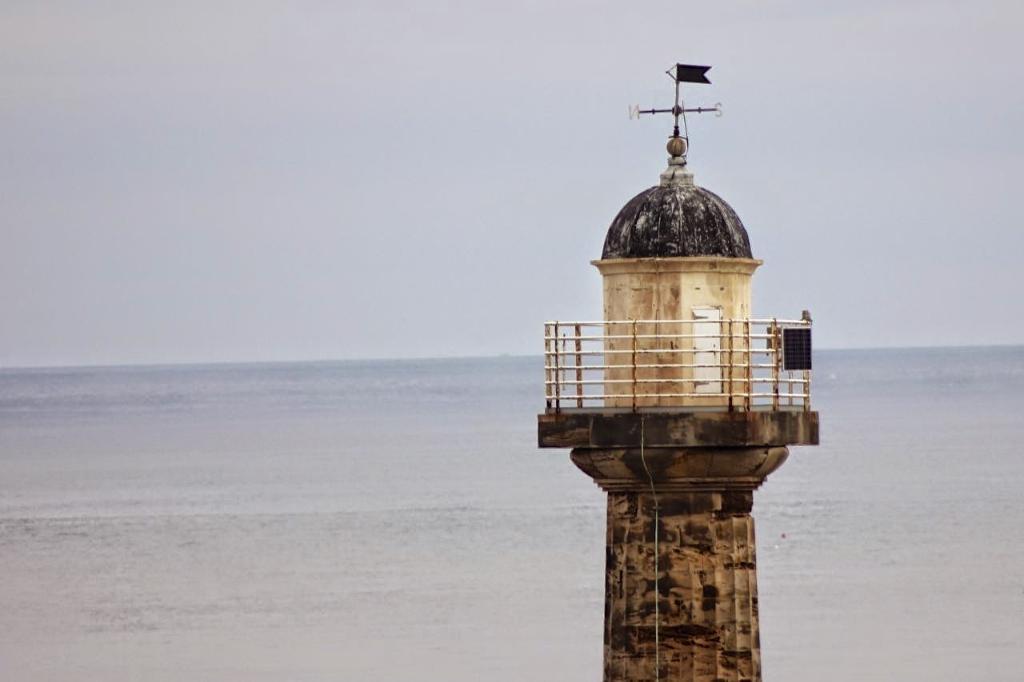In one or two sentences, can you explain what this image depicts? In this picture there is a tower on the right side of the image and there is water at the bottom side of the image. 